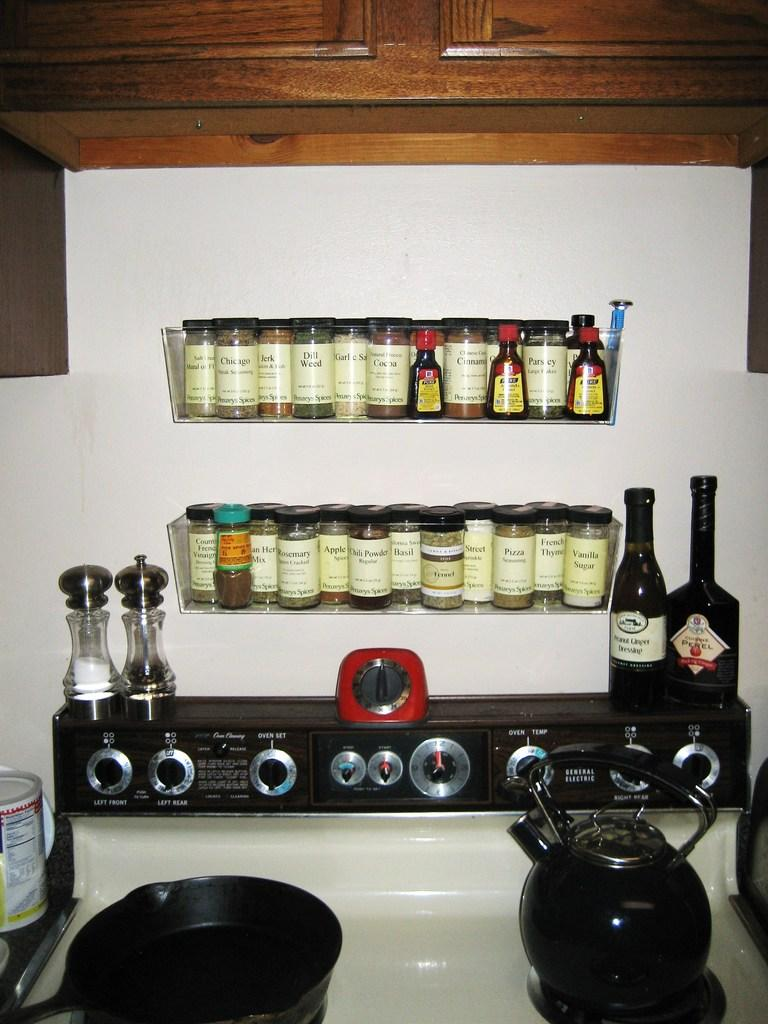<image>
Give a short and clear explanation of the subsequent image. Many seasonings on a shelf including dill weed on top of a stove. 